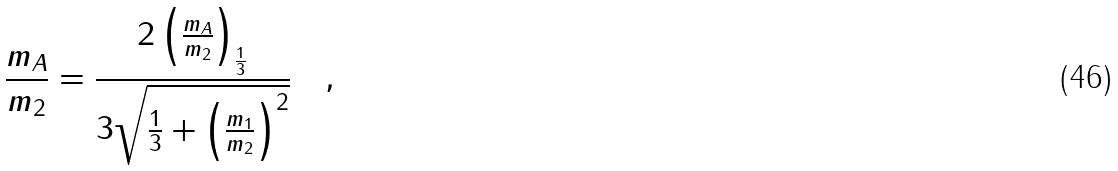<formula> <loc_0><loc_0><loc_500><loc_500>\frac { m _ { A } } { m _ { 2 } } = \frac { 2 \left ( \frac { m _ { A } } { m _ { 2 } } \right ) _ { \frac { 1 } { 3 } } } { 3 \sqrt { \frac { 1 } { 3 } + \left ( \frac { m _ { 1 } } { m _ { 2 } } \right ) ^ { 2 } } } \quad ,</formula> 